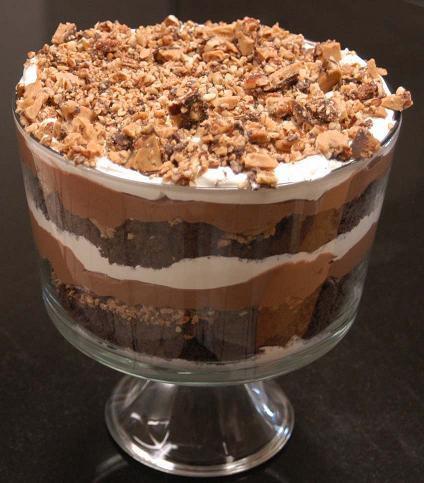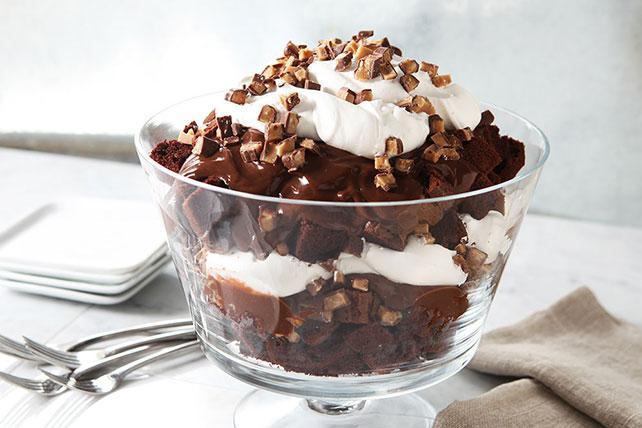The first image is the image on the left, the second image is the image on the right. Examine the images to the left and right. Is the description "Left image shows a dessert served in a footed glass with crumble-type garnish nearly covering the top." accurate? Answer yes or no. Yes. 